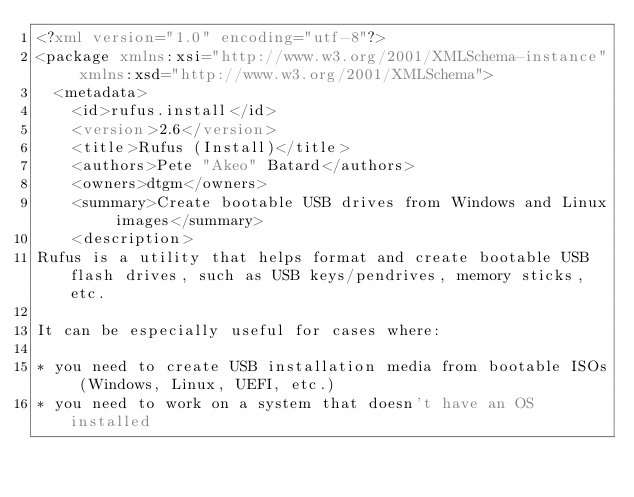<code> <loc_0><loc_0><loc_500><loc_500><_XML_><?xml version="1.0" encoding="utf-8"?>
<package xmlns:xsi="http://www.w3.org/2001/XMLSchema-instance" xmlns:xsd="http://www.w3.org/2001/XMLSchema">
  <metadata>
    <id>rufus.install</id>
    <version>2.6</version>
    <title>Rufus (Install)</title>
    <authors>Pete "Akeo" Batard</authors>
    <owners>dtgm</owners>
    <summary>Create bootable USB drives from Windows and Linux images</summary>
    <description>
Rufus is a utility that helps format and create bootable USB flash drives, such as USB keys/pendrives, memory sticks, etc.

It can be especially useful for cases where:

* you need to create USB installation media from bootable ISOs (Windows, Linux, UEFI, etc.)
* you need to work on a system that doesn't have an OS installed</code> 